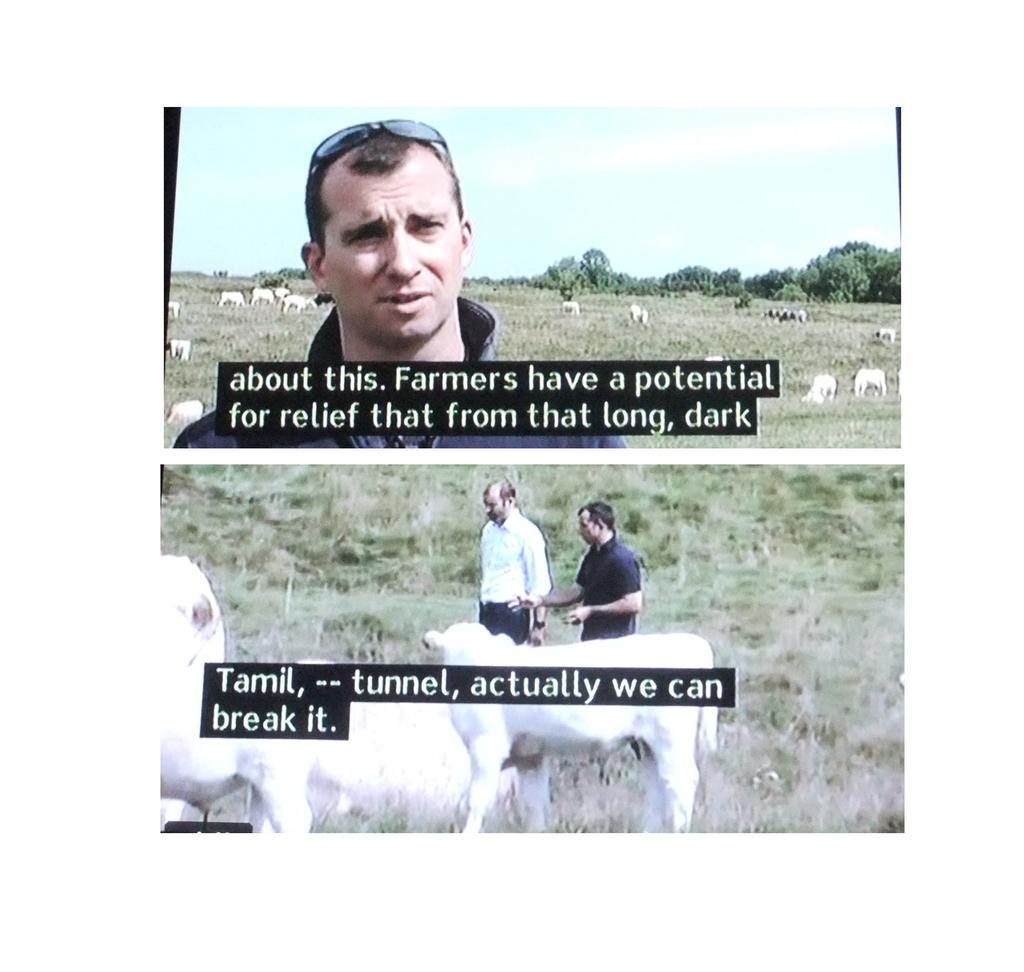Could you give a brief overview of what you see in this image? In this image, we can see some people and animals, And we can see some plants and trees. And we can see some text, and at the top we can see the sky. 